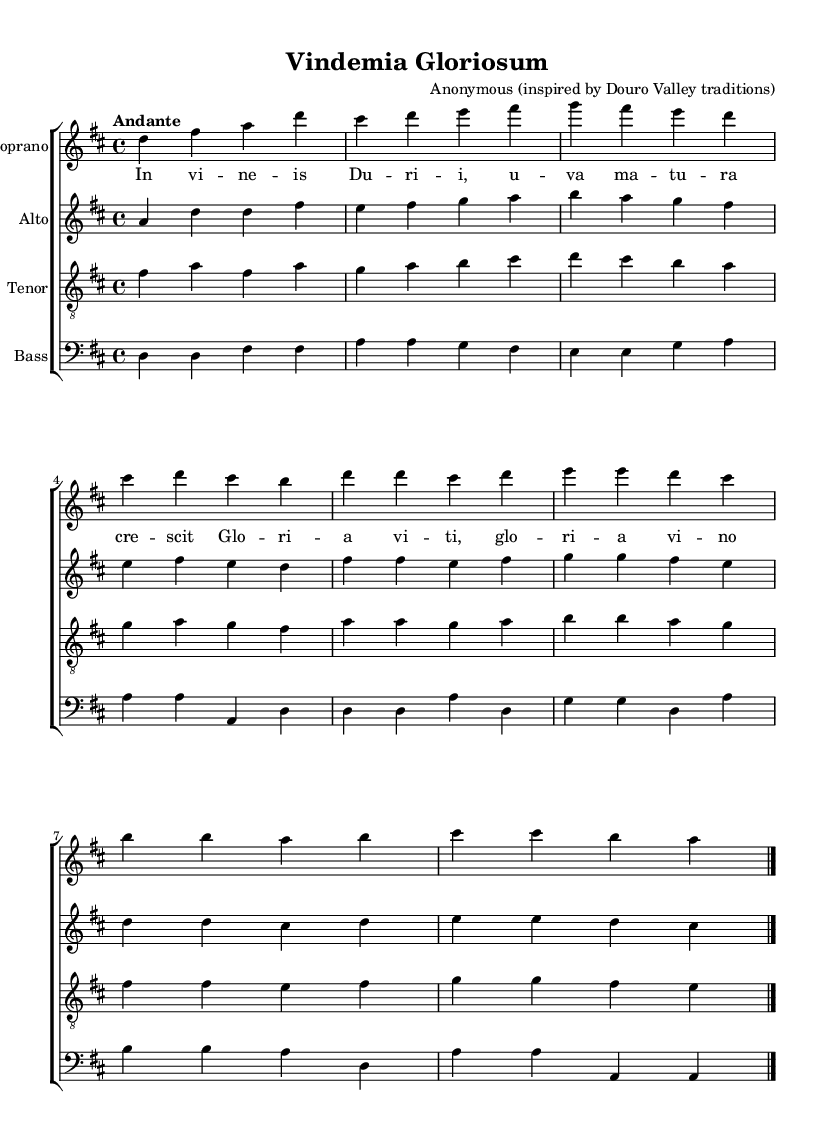What is the key signature of this music? The key signature is D major, which has two sharps (F# and C#). This is indicated at the beginning of the staff with the relevant sharps.
Answer: D major What is the time signature of this music? The time signature is 4/4, which means there are four beats in each measure, and the quarter note gets one beat. This is shown at the start of the score.
Answer: 4/4 What is the tempo indicated for the piece? The tempo marking is "Andante," which typically means at a moderate walking pace. This marking can be found at the beginning of the score.
Answer: Andante How many voices are present in the choral work? The piece includes four voices: Soprano, Alto, Tenor, and Bass, evident from the separate staves for each voice part in the score.
Answer: Four What is the title of the choral work? The title is "Vindemia Gloriosum," as indicated in the header of the sheet music.
Answer: Vindemia Gloriosum Which traditional winemaking element is referenced in the lyrics? The lyrics reference "wine" with the phrases that celebrate the growth and glory associated with winemaking, specifically mentioning "gloria vitis" which translates to "glory of the vine."
Answer: Glory of the vine 